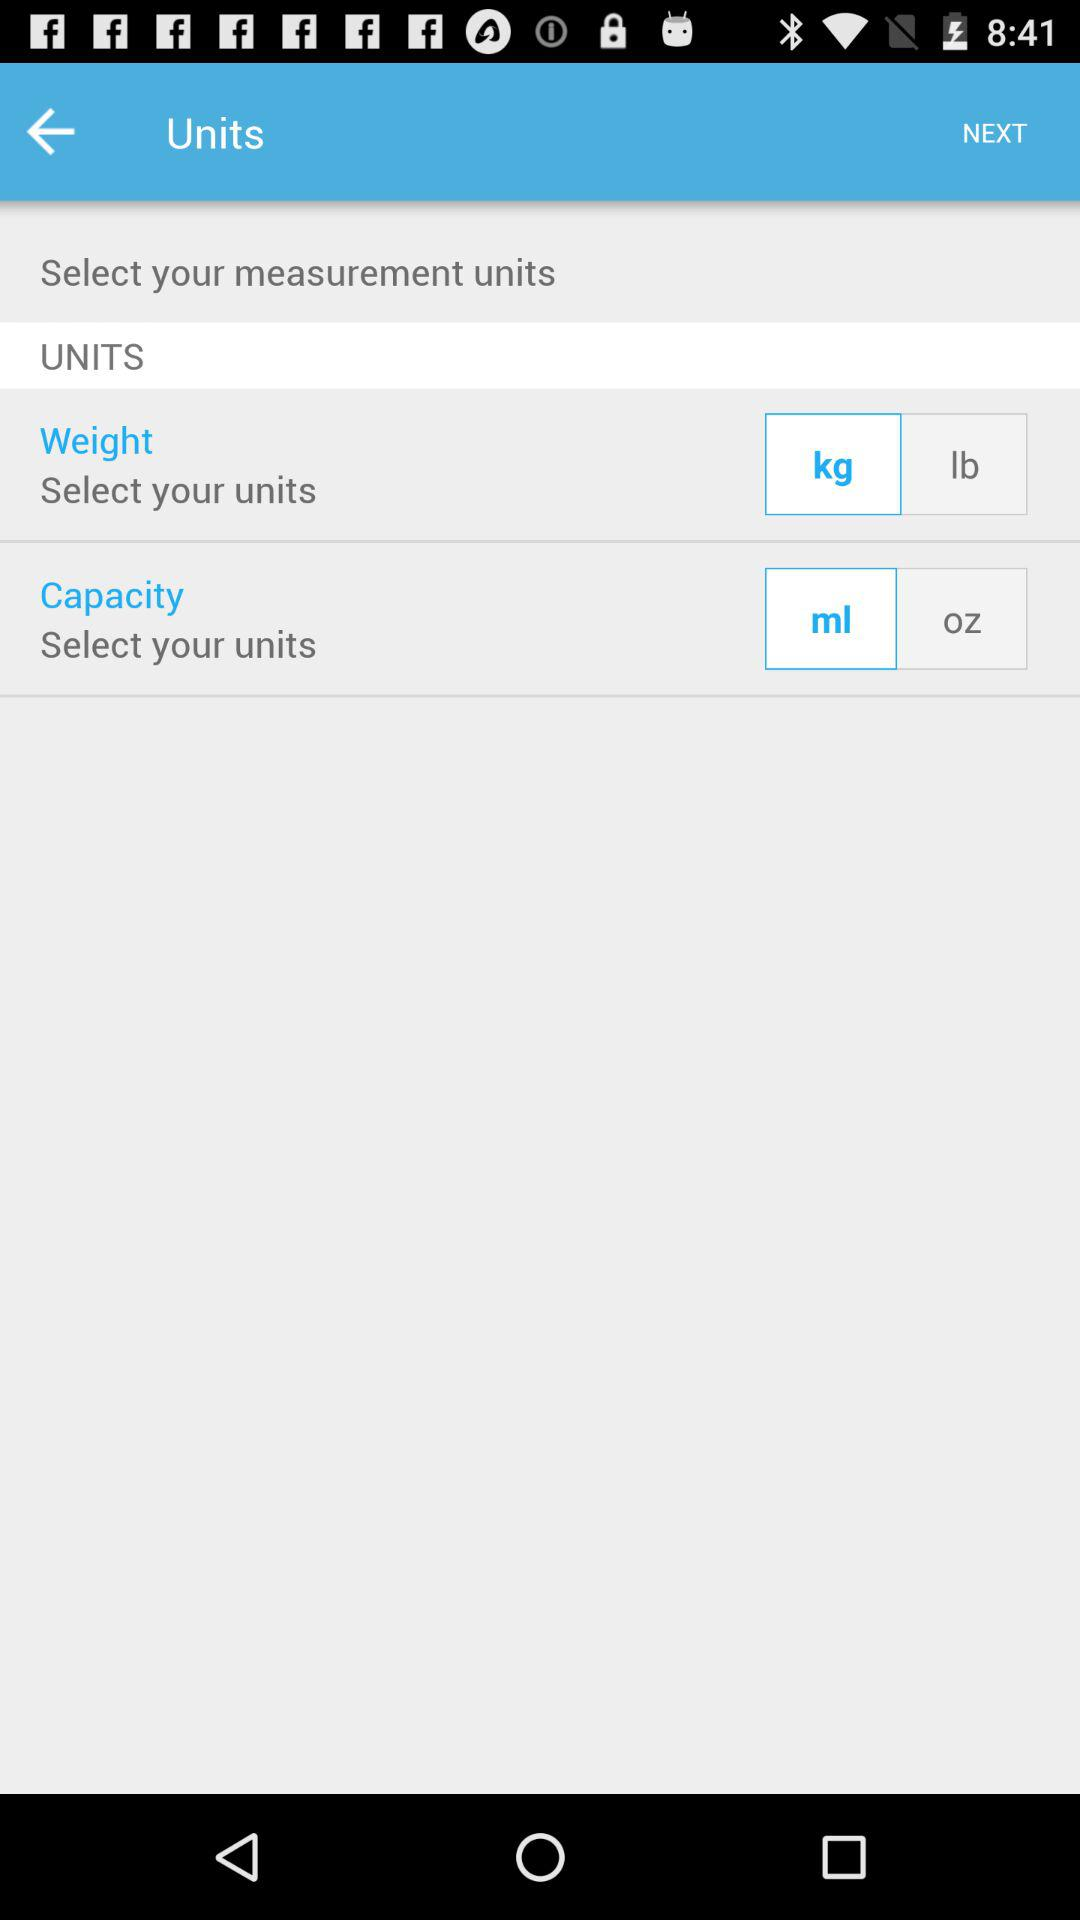Which option is selected for weight? The selected option for weight is "kg". 